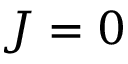Convert formula to latex. <formula><loc_0><loc_0><loc_500><loc_500>J = 0</formula> 